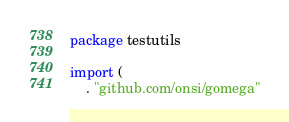Convert code to text. <code><loc_0><loc_0><loc_500><loc_500><_Go_>package testutils

import (
	. "github.com/onsi/gomega"
</code> 